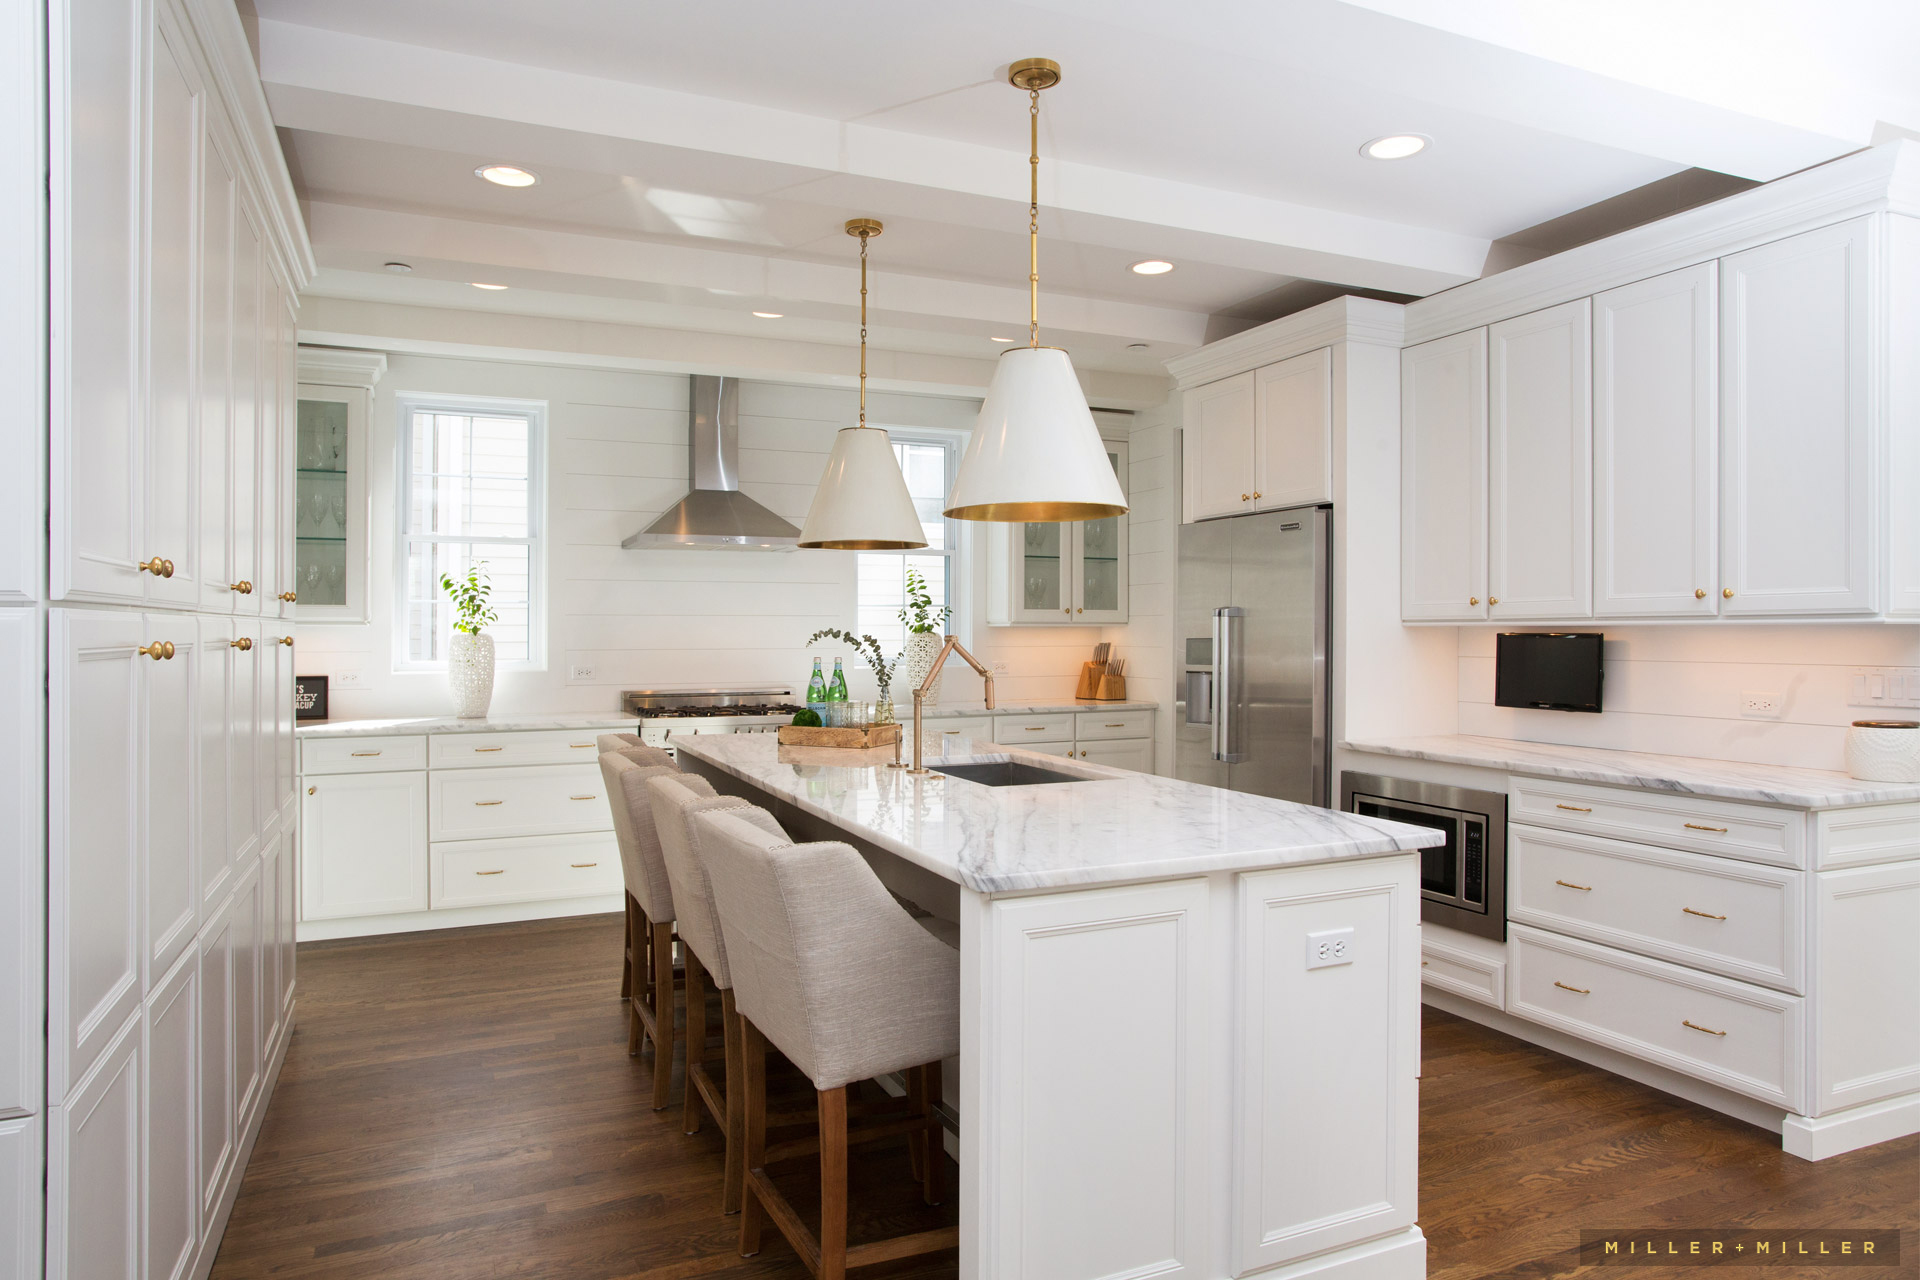What do you find most striking about this kitchen design? The most striking element of this kitchen design is the harmonious blend of elegance and functionality. The bright white cabinetry and walls create a clean, airy ambiance, while the marble countertops introduce a touch of luxury. The gold accents on the handles and light fixtures add a refined contrast, enhancing the overall aesthetic with a touch of sophistication. How does the choice of materials enhance the functionality of the kitchen? The choice of materials in this kitchen significantly boosts both its functionality and longevity. The marble countertops offer a durable and heat-resistant surface for food preparation. The stainless steel appliances, including the range hood, refrigerator, and oven, are robust, easy to clean, and highly resistant to corrosion. The wooden flooring, besides lending warmth to the space, is durable and complements the overall design. Collectively, these materials not only ensure aesthetic appeal but also cater to the practical needs of a busy kitchen. What kind of atmosphere does this kitchen create for gatherings? This kitchen fosters a welcoming and inviting atmosphere ideal for gatherings. The open layout and ample seating around the island make it perfect for socializing while cooking. The large windows allow plenty of natural light to flood the space, enhancing the cheerful and airy ambiance. The modern yet cozy design elements, such as the wooden floors and soft-hued cabinetry, make it a warm and comfortable environment for family and friends to gather and enjoy meals together. 